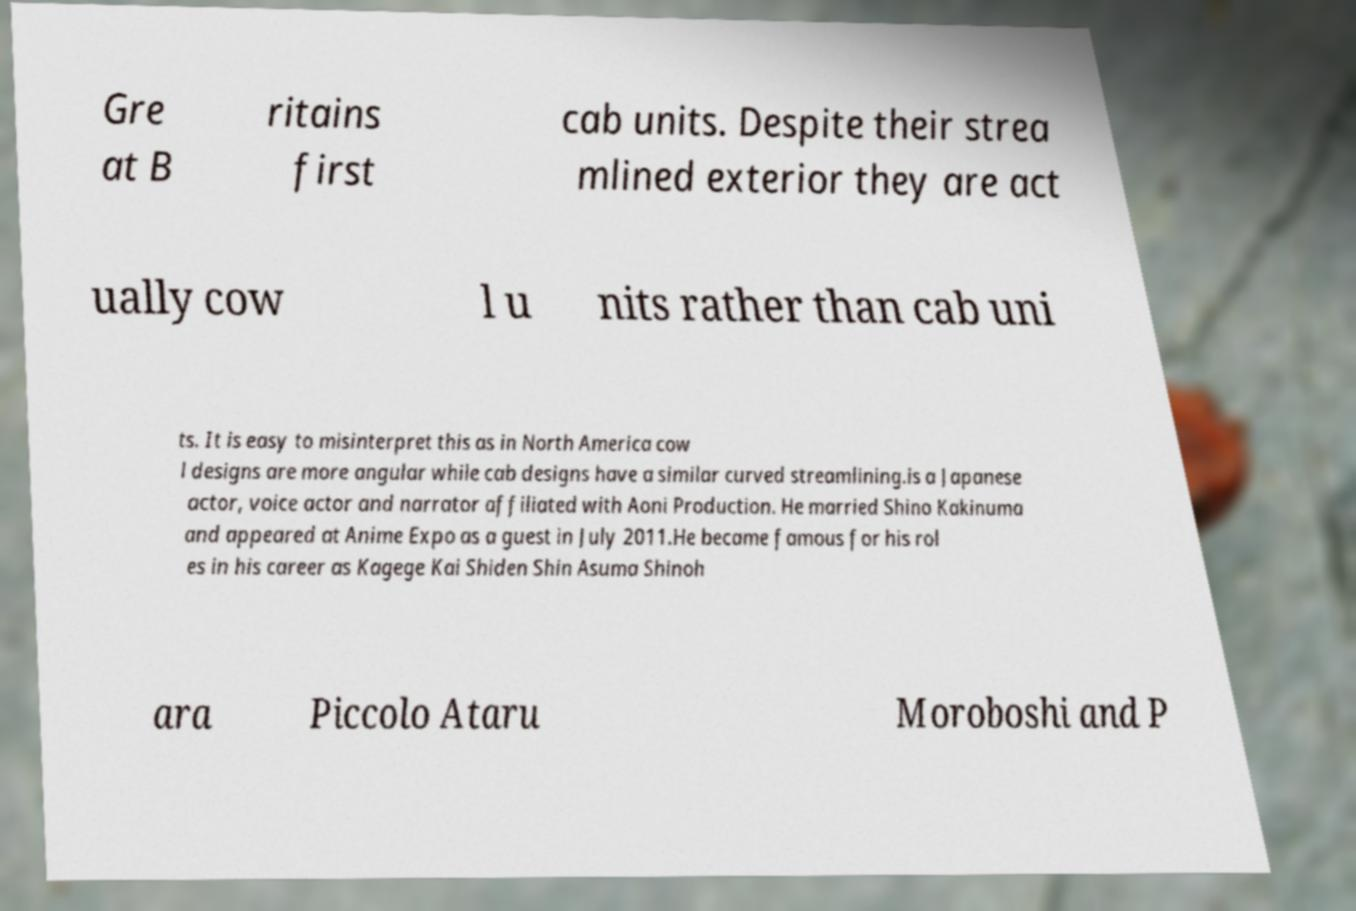What messages or text are displayed in this image? I need them in a readable, typed format. Gre at B ritains first cab units. Despite their strea mlined exterior they are act ually cow l u nits rather than cab uni ts. It is easy to misinterpret this as in North America cow l designs are more angular while cab designs have a similar curved streamlining.is a Japanese actor, voice actor and narrator affiliated with Aoni Production. He married Shino Kakinuma and appeared at Anime Expo as a guest in July 2011.He became famous for his rol es in his career as Kagege Kai Shiden Shin Asuma Shinoh ara Piccolo Ataru Moroboshi and P 